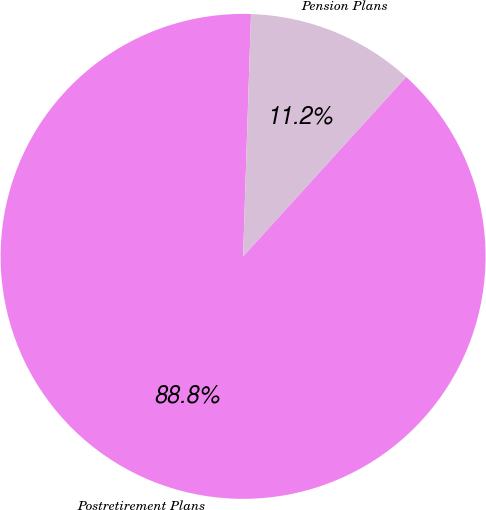Convert chart. <chart><loc_0><loc_0><loc_500><loc_500><pie_chart><fcel>Postretirement Plans<fcel>Pension Plans<nl><fcel>88.78%<fcel>11.22%<nl></chart> 